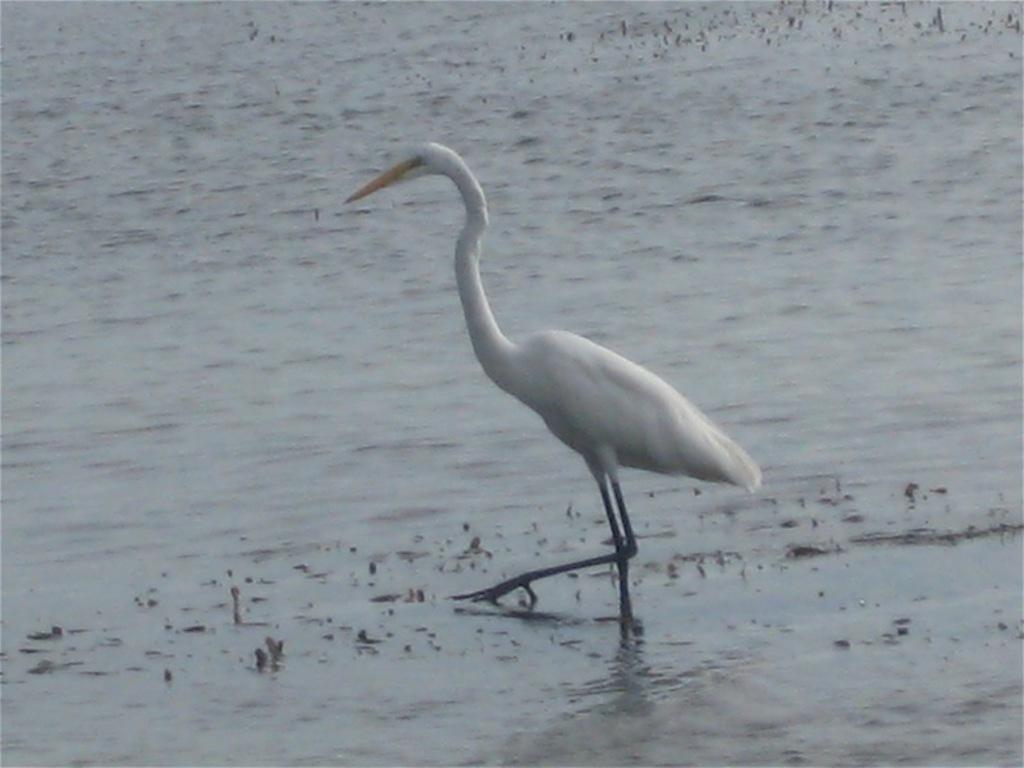How would you summarize this image in a sentence or two? This image is taken outdoors. At the bottom of the image there is a pond with water. In the middle of the image there is a crane. 